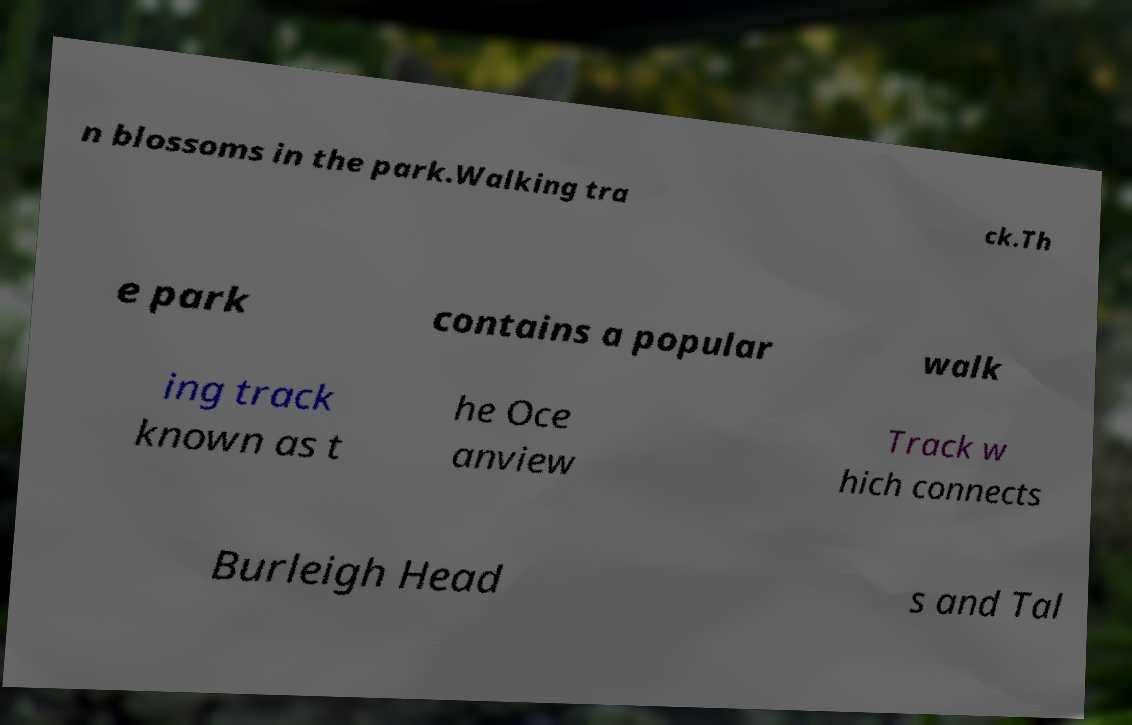Please identify and transcribe the text found in this image. n blossoms in the park.Walking tra ck.Th e park contains a popular walk ing track known as t he Oce anview Track w hich connects Burleigh Head s and Tal 